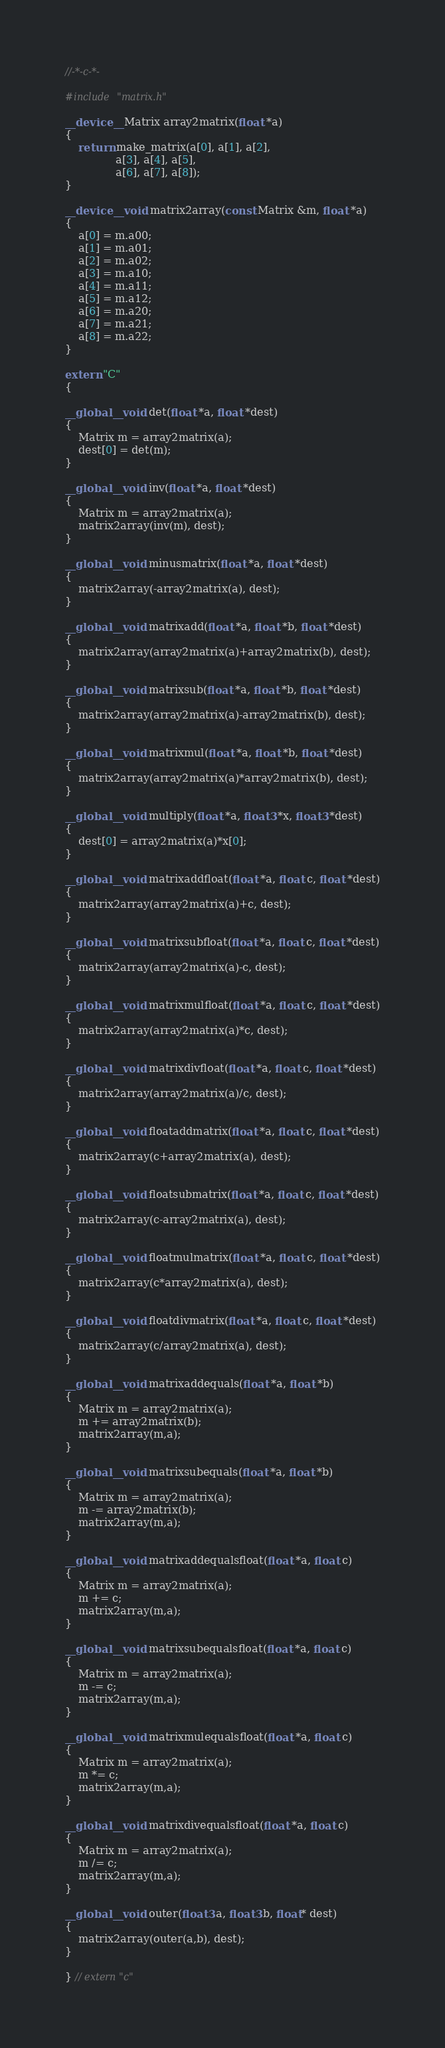<code> <loc_0><loc_0><loc_500><loc_500><_Cuda_>//-*-c-*-

#include "matrix.h"

__device__ Matrix array2matrix(float *a)
{
	return make_matrix(a[0], a[1], a[2],
			   a[3], a[4], a[5],
			   a[6], a[7], a[8]);
}

__device__ void matrix2array(const Matrix &m, float *a)
{
	a[0] = m.a00;
	a[1] = m.a01;
	a[2] = m.a02;
	a[3] = m.a10;
	a[4] = m.a11;
	a[5] = m.a12;
	a[6] = m.a20;
	a[7] = m.a21;
	a[8] = m.a22;
}

extern "C"
{

__global__ void det(float *a, float *dest)
{
	Matrix m = array2matrix(a);
	dest[0] = det(m);
}

__global__ void inv(float *a, float *dest)
{
	Matrix m = array2matrix(a);
	matrix2array(inv(m), dest);
}

__global__ void minusmatrix(float *a, float *dest)
{
	matrix2array(-array2matrix(a), dest);
}

__global__ void matrixadd(float *a, float *b, float *dest)
{
	matrix2array(array2matrix(a)+array2matrix(b), dest);
}

__global__ void matrixsub(float *a, float *b, float *dest)
{
	matrix2array(array2matrix(a)-array2matrix(b), dest);
}

__global__ void matrixmul(float *a, float *b, float *dest)
{
	matrix2array(array2matrix(a)*array2matrix(b), dest);
}

__global__ void multiply(float *a, float3 *x, float3 *dest)
{
	dest[0] = array2matrix(a)*x[0];
}

__global__ void matrixaddfloat(float *a, float c, float *dest)
{
	matrix2array(array2matrix(a)+c, dest);
}

__global__ void matrixsubfloat(float *a, float c, float *dest)
{
	matrix2array(array2matrix(a)-c, dest);
}

__global__ void matrixmulfloat(float *a, float c, float *dest)
{
	matrix2array(array2matrix(a)*c, dest);
}

__global__ void matrixdivfloat(float *a, float c, float *dest)
{
	matrix2array(array2matrix(a)/c, dest);
}

__global__ void floataddmatrix(float *a, float c, float *dest)
{
	matrix2array(c+array2matrix(a), dest);
}

__global__ void floatsubmatrix(float *a, float c, float *dest)
{
	matrix2array(c-array2matrix(a), dest);
}

__global__ void floatmulmatrix(float *a, float c, float *dest)
{
	matrix2array(c*array2matrix(a), dest);
}

__global__ void floatdivmatrix(float *a, float c, float *dest)
{
	matrix2array(c/array2matrix(a), dest);
}

__global__ void matrixaddequals(float *a, float *b)
{
	Matrix m = array2matrix(a);
	m += array2matrix(b);
	matrix2array(m,a);
}

__global__ void matrixsubequals(float *a, float *b)
{
	Matrix m = array2matrix(a);
	m -= array2matrix(b);
	matrix2array(m,a);
}

__global__ void matrixaddequalsfloat(float *a, float c)
{
	Matrix m = array2matrix(a);
	m += c;
	matrix2array(m,a);
}

__global__ void matrixsubequalsfloat(float *a, float c)
{
	Matrix m = array2matrix(a);
	m -= c;
	matrix2array(m,a);
}

__global__ void matrixmulequalsfloat(float *a, float c)
{
	Matrix m = array2matrix(a);
	m *= c;
	matrix2array(m,a);
}

__global__ void matrixdivequalsfloat(float *a, float c)
{
	Matrix m = array2matrix(a);
	m /= c;
	matrix2array(m,a);
}

__global__ void outer(float3 a, float3 b, float* dest)
{
	matrix2array(outer(a,b), dest);
}

} // extern "c"
</code> 